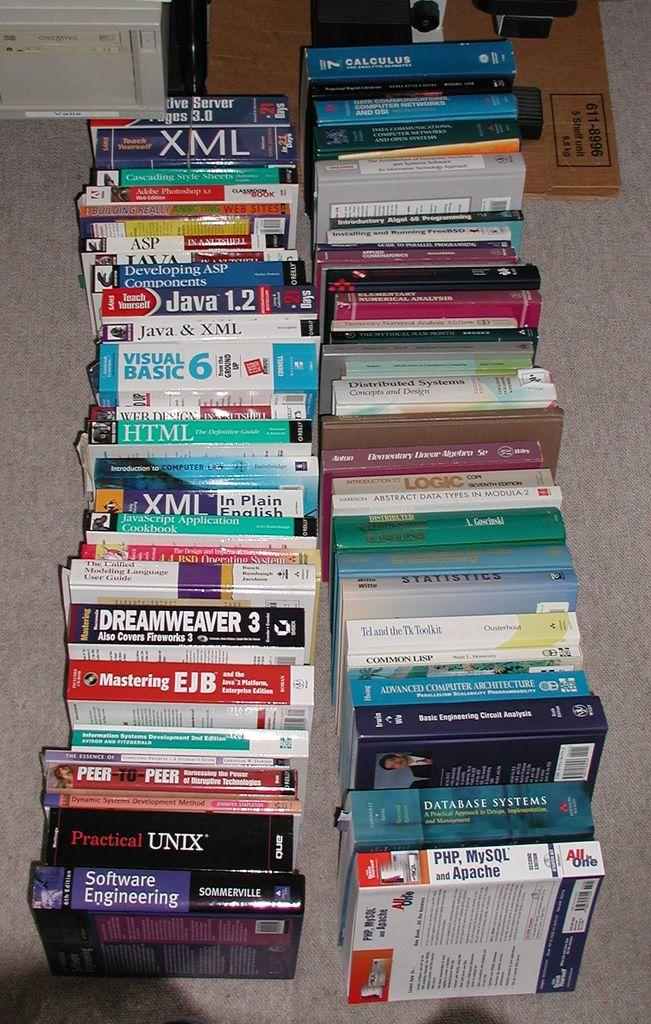<image>
Write a terse but informative summary of the picture. Several books are laying together, including "Software Engineering." 